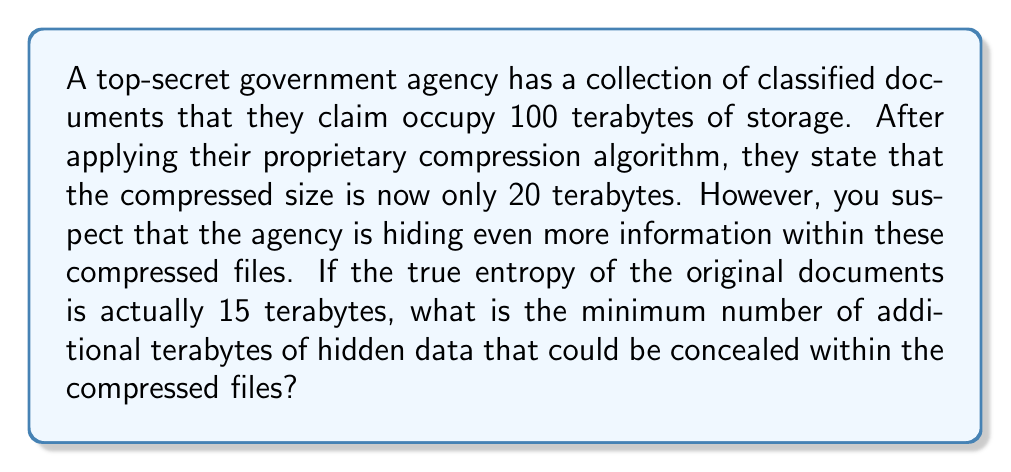Can you answer this question? To solve this problem, we need to understand the concepts of data compression and information entropy. Let's break it down step-by-step:

1) First, let's calculate the claimed compression ratio:
   $$\text{Compression Ratio} = \frac{\text{Original Size}}{\text{Compressed Size}} = \frac{100 \text{ TB}}{20 \text{ TB}} = 5$$

2) However, we know that the true entropy of the original documents is only 15 TB. In information theory, the entropy represents the minimum amount of data needed to represent the information content. No lossless compression can compress data to a size smaller than its entropy.

3) If the true entropy is 15 TB, then the maximum achievable compression ratio would be:
   $$\text{Max Compression Ratio} = \frac{100 \text{ TB}}{15 \text{ TB}} \approx 6.67$$

4) This means that the minimum possible size of the compressed data should be 15 TB, not 20 TB as claimed.

5) The difference between the claimed compressed size and the minimum possible size represents the potential hidden data:
   $$\text{Hidden Data} = \text{Claimed Compressed Size} - \text{Minimum Possible Size}$$
   $$\text{Hidden Data} = 20 \text{ TB} - 15 \text{ TB} = 5 \text{ TB}$$

Therefore, there could be at least 5 TB of hidden data concealed within the compressed files.
Answer: 5 terabytes 